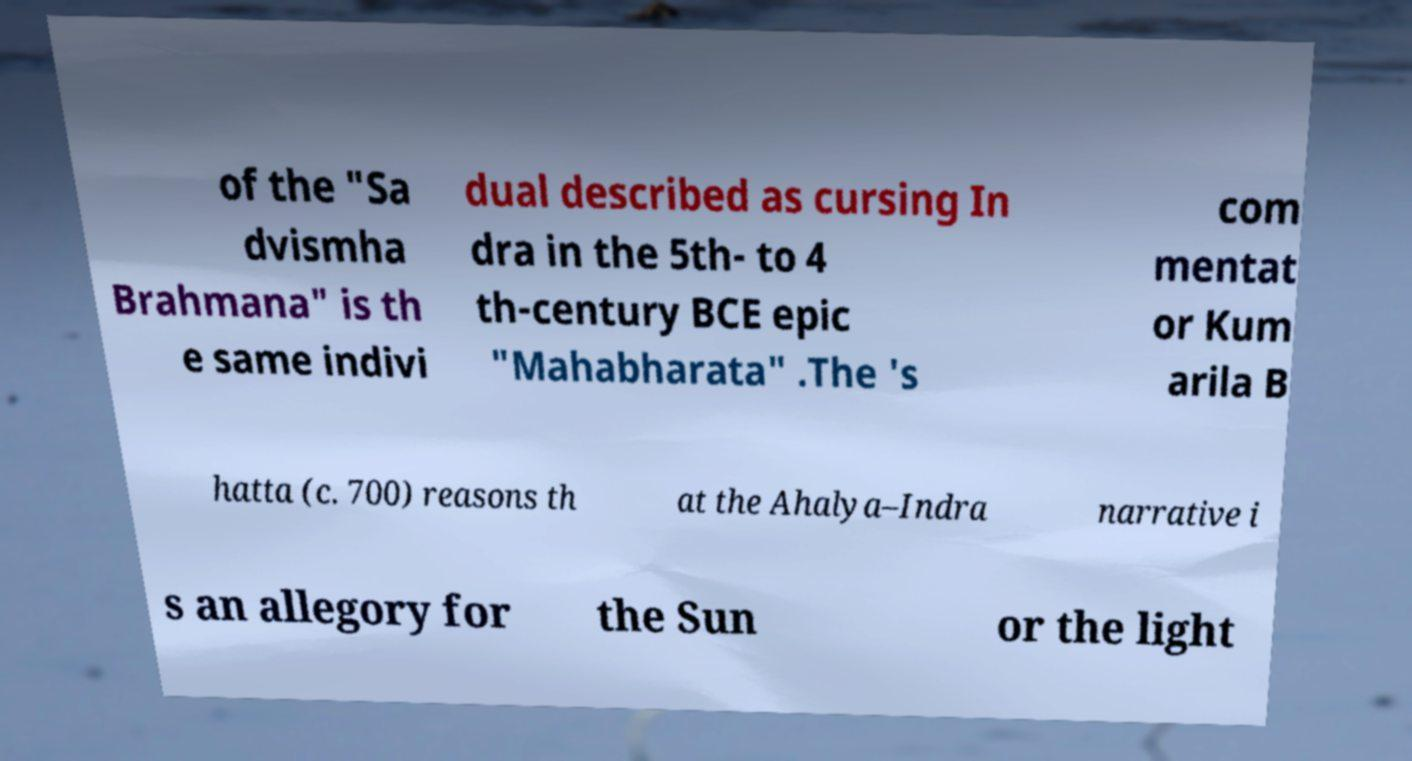Please identify and transcribe the text found in this image. of the "Sa dvismha Brahmana" is th e same indivi dual described as cursing In dra in the 5th- to 4 th-century BCE epic "Mahabharata" .The 's com mentat or Kum arila B hatta (c. 700) reasons th at the Ahalya–Indra narrative i s an allegory for the Sun or the light 